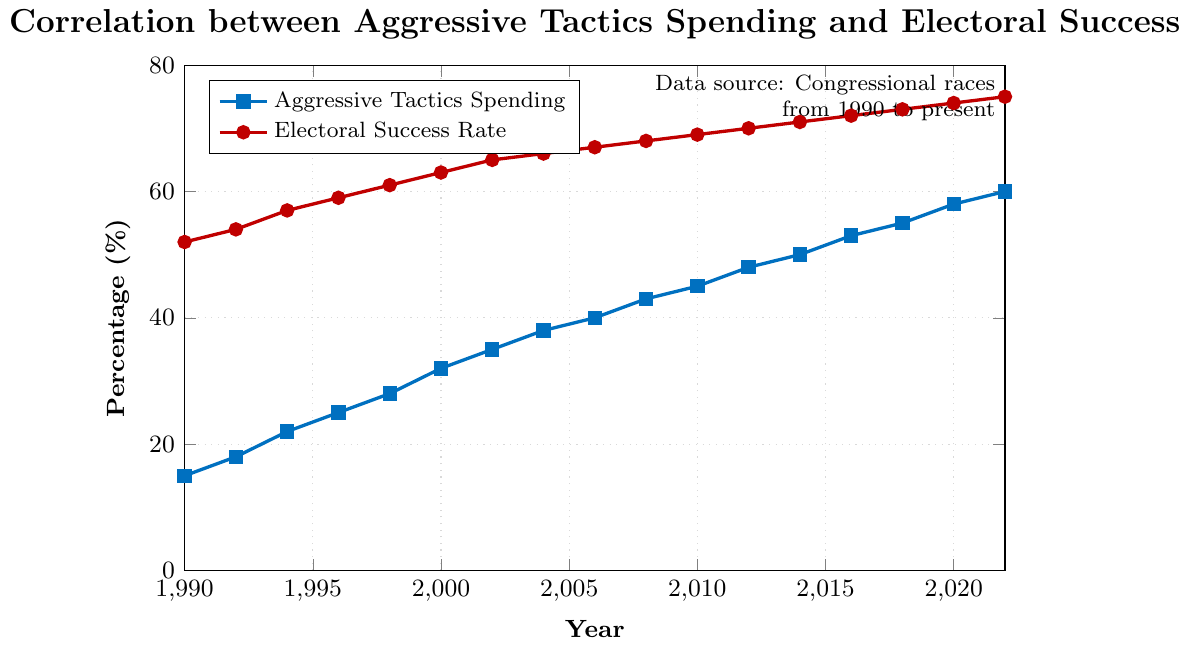What's the range of aggressive tactics spending over the years? The minimum value of aggressive tactics spending is 15% in 1990 and the maximum value is 60% in 2022. To find the range, subtract the minimum value from the maximum value: 60% - 15% = 45%.
Answer: 45% How much did the electoral success rate increase from 1990 to 2000? The electoral success rate in 1990 was 52% and in 2000 it was 63%. The increase is found by subtracting the success rate in 1990 from that in 2000: 63% - 52% = 11%.
Answer: 11% Between which two consecutive years did aggressive tactics spending increase the most? The increases between consecutive years are calculated as follows: 1992-1990 (18%-15%=3%), 1994-1992 (22%-18%=4%), 1996-1994 (25%-22%=3%), 1998-1996 (28%-25%=3%), 2000-1998 (32%-28%=4%), 2002-2000 (35%-32%=3%), 2004-2002 (38%-35%=3%), 2006-2004 (40%-38%=2%), 2008-2006 (43%-40%=3%), 2010-2008 (45%-43%=2%), 2012-2010 (48%-45%=3%), 2014-2012 (50%-48%=2%), 2016-2014 (53%-50%=3%), 2018-2016 (55%-53%=2%), 2020-2018 (58%-55%=3%), 2022-2020 (60%-58%=2%). Therefore, the largest increase of 4% occurred in the periods 1994-1992 and 2000-1998.
Answer: 1994-1992 and 2000-1998 What is the average electoral success rate over the entire period? Add all the electoral success rates from 1990 to 2022 and divide by the number of years. Sum = 52 + 54 + 57 + 59 + 61 + 63 + 65 + 66 + 67 + 68 + 69 + 70 + 71 + 72 + 73 + 74 + 75 = 1126. The average is 1126 / 17 = 66.24%.
Answer: 66.24% How does the trend in aggressive tactics spending compare with the trend in electoral success rate? Both aggressive tactics spending, shown in blue, and electoral success rate, shown in red, have increased steadily from 1990 to 2022. This parallel upward trend indicates a positive correlation between the variables over the years.
Answer: Positive correlation By how much did the electoral success rate lag behind aggressive tactics spending in 2000? In 2000, aggressive tactics spending was 32% and the electoral success rate was 63%. The lag between the spending and success rate is calculated by subtracting the spending from the success rate: 63% - 32% = 31%.
Answer: 31% What was the percentage point difference between aggressive tactics spending and electoral success rate in 2016? In 2016, aggressive tactics spending was 53% and the electoral success rate was 72%. The difference is calculated as: 72% - 53% = 19%.
Answer: 19% How consistent is the increase in electoral success rate compared to the increase in aggressive tactics spending? Both aggressive tactics spending and electoral success rate show a consistent upward trend, with both variables gradually increasing over time. While electoral success rate increases appear slightly more moderated, both metrics demonstrate a steady rise without major fluctuations.
Answer: Consistent with moderate rise in success rate 